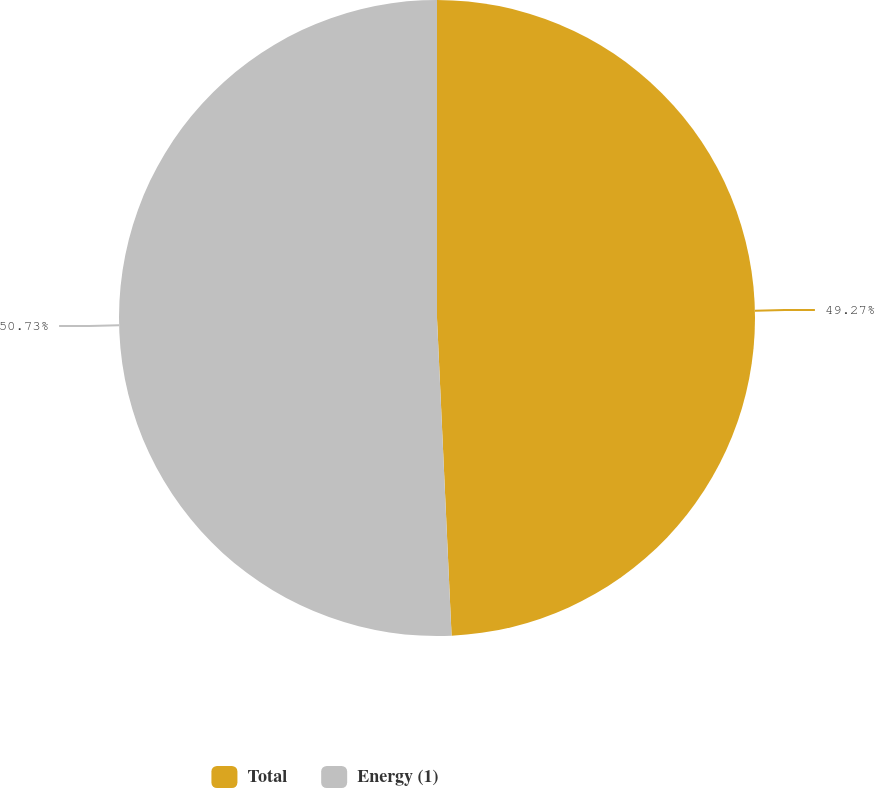Convert chart to OTSL. <chart><loc_0><loc_0><loc_500><loc_500><pie_chart><fcel>Total<fcel>Energy (1)<nl><fcel>49.27%<fcel>50.73%<nl></chart> 